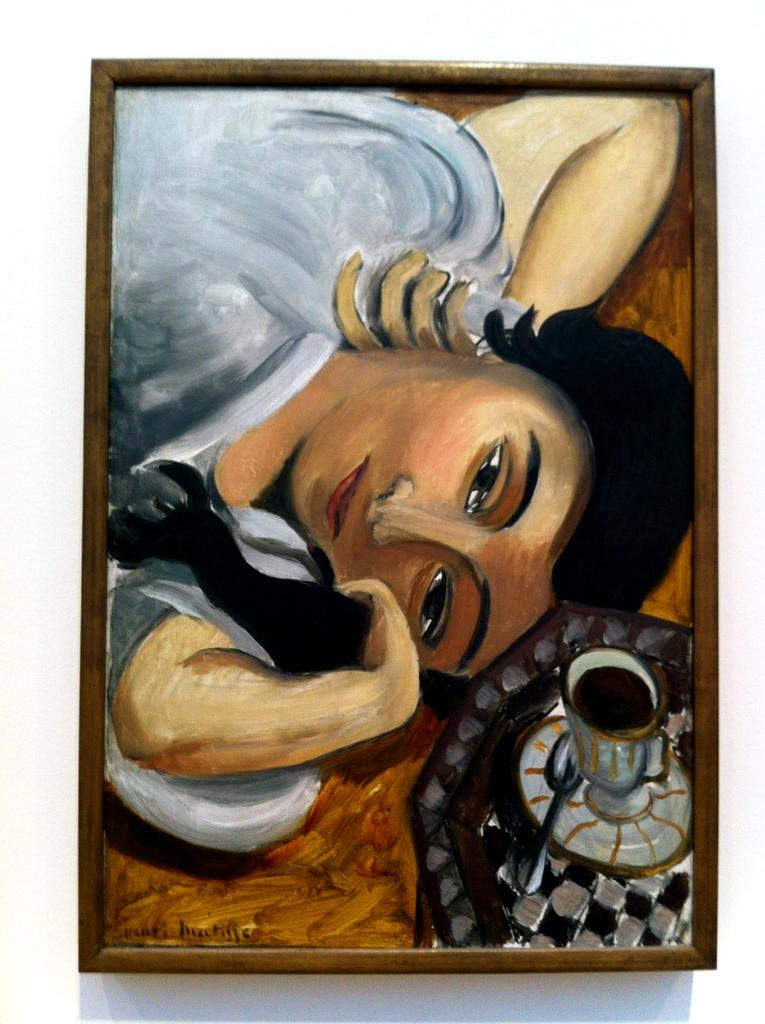What is depicted in the painting in the image? There is a painting of a person in the image. What object can be seen in the hands of the person in the painting? There is a cup in the painting. What color is the background of the painting? The background of the painting is white. How many feet are visible in the painting? There is no information about feet in the painting, as it only depicts a person holding a cup against a white background. 